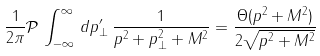Convert formula to latex. <formula><loc_0><loc_0><loc_500><loc_500>\frac { 1 } { 2 \pi } \mathcal { P } \, \int _ { - \infty } ^ { \infty } \, d p _ { \perp } ^ { \prime } \, \frac { 1 } { p ^ { 2 } + p _ { \perp } ^ { 2 } + M ^ { 2 } } = \frac { \Theta ( p ^ { 2 } + M ^ { 2 } ) } { 2 \sqrt { p ^ { 2 } + M ^ { 2 } } }</formula> 